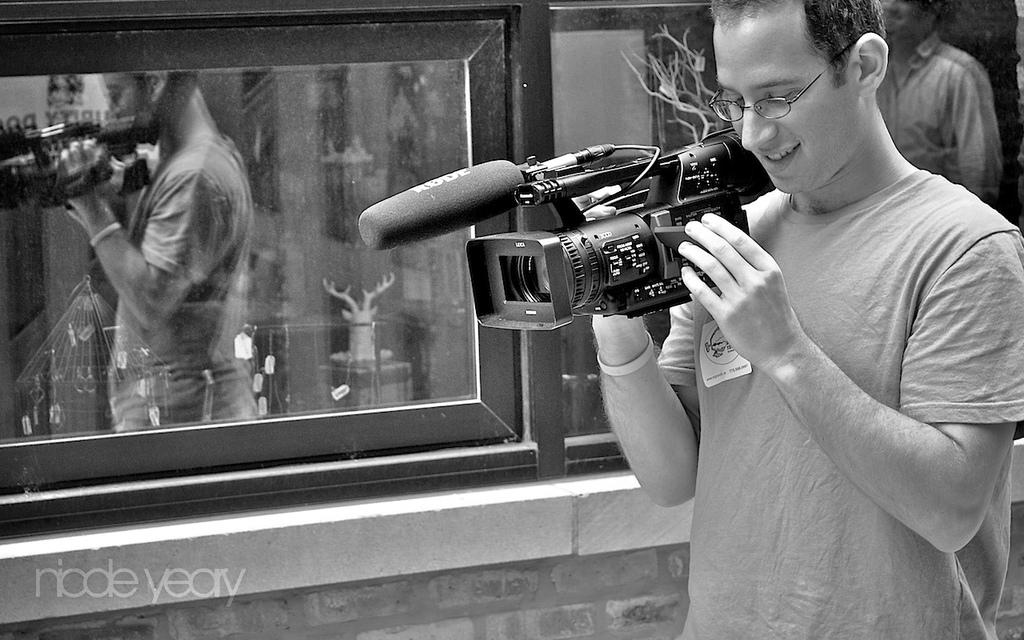What is the man in the image wearing? The man is wearing a t-shirt. What is the man's facial expression in the image? The man is smiling. What is the man holding in the image? The man is holding a camera. What can be seen in the background of the image? There is a window and a person in the background of the image. Can you tell me how many toads are visible in the image? There are no toads present in the image. What type of girl can be seen in the image? There is no girl present in the image. 